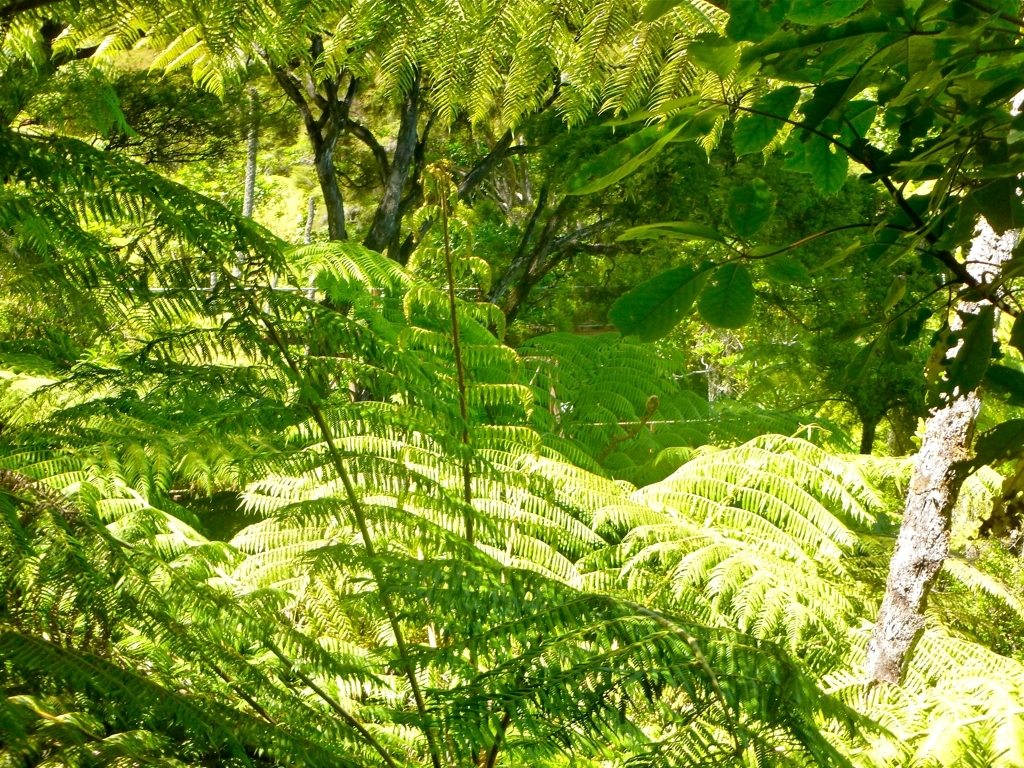Can you infer the climate of the area from the vegetation seen in the image? The vegetation in the image suggests a moist, tropical climate. The presence of large ferns is indicative of an environment that is humid and shaded, which are common conditions in tropical rainforests. 